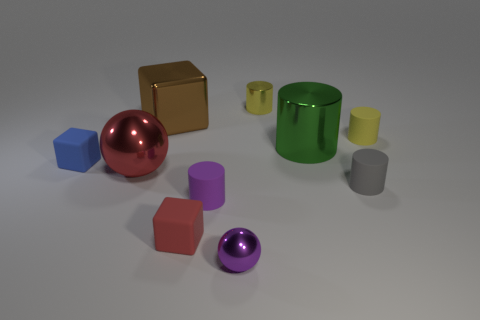What material is the tiny thing that is the same color as the big metallic ball?
Your answer should be very brief. Rubber. How many red objects are either big balls or metal cubes?
Your response must be concise. 1. Is the number of big green metallic things greater than the number of small yellow shiny cubes?
Offer a terse response. Yes. What color is the ball that is the same size as the yellow rubber cylinder?
Provide a succinct answer. Purple. How many balls are yellow rubber objects or tiny gray objects?
Provide a short and direct response. 0. There is a small blue matte object; is its shape the same as the purple shiny thing that is to the right of the blue rubber object?
Provide a short and direct response. No. What number of red shiny things are the same size as the brown metallic thing?
Offer a very short reply. 1. There is a large metallic thing to the right of the small metallic sphere; is its shape the same as the small object to the left of the large brown metal block?
Your answer should be very brief. No. There is a thing that is the same color as the large shiny ball; what is its shape?
Ensure brevity in your answer.  Cube. There is a shiny ball behind the purple thing behind the small purple shiny object; what color is it?
Give a very brief answer. Red. 